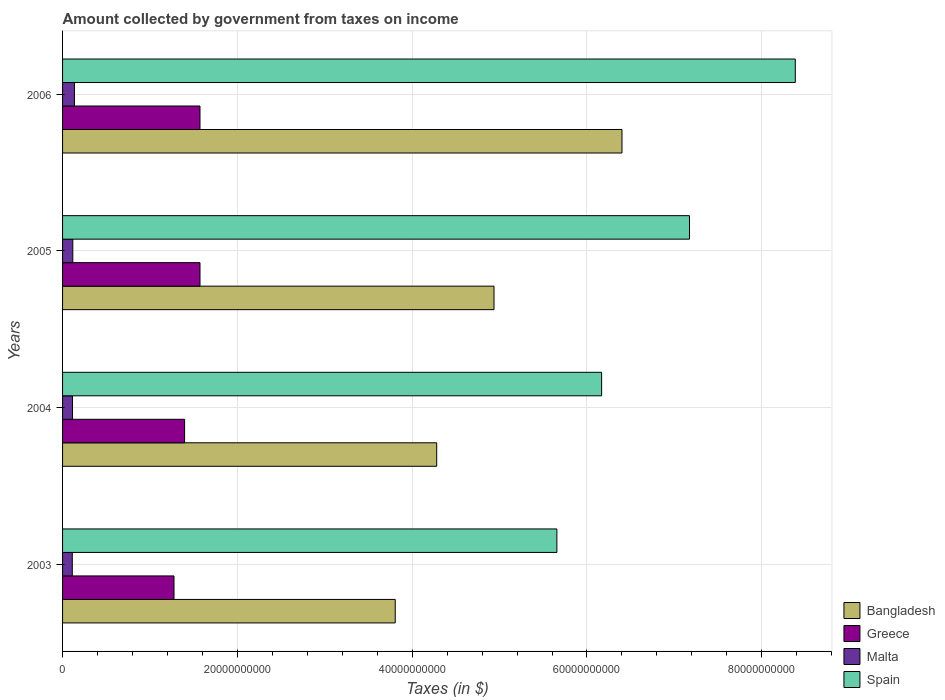How many groups of bars are there?
Ensure brevity in your answer.  4. Are the number of bars per tick equal to the number of legend labels?
Ensure brevity in your answer.  Yes. How many bars are there on the 4th tick from the top?
Provide a short and direct response. 4. How many bars are there on the 1st tick from the bottom?
Offer a terse response. 4. What is the label of the 2nd group of bars from the top?
Provide a short and direct response. 2005. In how many cases, is the number of bars for a given year not equal to the number of legend labels?
Your response must be concise. 0. What is the amount collected by government from taxes on income in Bangladesh in 2003?
Your response must be concise. 3.81e+1. Across all years, what is the maximum amount collected by government from taxes on income in Malta?
Give a very brief answer. 1.36e+09. Across all years, what is the minimum amount collected by government from taxes on income in Spain?
Ensure brevity in your answer.  5.66e+1. What is the total amount collected by government from taxes on income in Spain in the graph?
Keep it short and to the point. 2.74e+11. What is the difference between the amount collected by government from taxes on income in Spain in 2004 and the amount collected by government from taxes on income in Malta in 2006?
Offer a terse response. 6.03e+1. What is the average amount collected by government from taxes on income in Greece per year?
Offer a very short reply. 1.45e+1. In the year 2006, what is the difference between the amount collected by government from taxes on income in Greece and amount collected by government from taxes on income in Spain?
Your response must be concise. -6.81e+1. In how many years, is the amount collected by government from taxes on income in Bangladesh greater than 84000000000 $?
Make the answer very short. 0. What is the ratio of the amount collected by government from taxes on income in Greece in 2003 to that in 2004?
Offer a terse response. 0.91. Is the amount collected by government from taxes on income in Bangladesh in 2004 less than that in 2006?
Offer a very short reply. Yes. Is the difference between the amount collected by government from taxes on income in Greece in 2003 and 2005 greater than the difference between the amount collected by government from taxes on income in Spain in 2003 and 2005?
Your answer should be very brief. Yes. What is the difference between the highest and the second highest amount collected by government from taxes on income in Bangladesh?
Give a very brief answer. 1.46e+1. What is the difference between the highest and the lowest amount collected by government from taxes on income in Spain?
Your response must be concise. 2.73e+1. Is the sum of the amount collected by government from taxes on income in Malta in 2003 and 2004 greater than the maximum amount collected by government from taxes on income in Spain across all years?
Your answer should be very brief. No. Is it the case that in every year, the sum of the amount collected by government from taxes on income in Malta and amount collected by government from taxes on income in Spain is greater than the sum of amount collected by government from taxes on income in Greece and amount collected by government from taxes on income in Bangladesh?
Your answer should be compact. No. What does the 3rd bar from the bottom in 2006 represents?
Provide a short and direct response. Malta. What is the difference between two consecutive major ticks on the X-axis?
Offer a very short reply. 2.00e+1. Does the graph contain grids?
Offer a terse response. Yes. How many legend labels are there?
Provide a short and direct response. 4. What is the title of the graph?
Make the answer very short. Amount collected by government from taxes on income. Does "Sint Maarten (Dutch part)" appear as one of the legend labels in the graph?
Give a very brief answer. No. What is the label or title of the X-axis?
Ensure brevity in your answer.  Taxes (in $). What is the label or title of the Y-axis?
Keep it short and to the point. Years. What is the Taxes (in $) in Bangladesh in 2003?
Offer a very short reply. 3.81e+1. What is the Taxes (in $) in Greece in 2003?
Your response must be concise. 1.28e+1. What is the Taxes (in $) of Malta in 2003?
Offer a very short reply. 1.11e+09. What is the Taxes (in $) in Spain in 2003?
Your response must be concise. 5.66e+1. What is the Taxes (in $) of Bangladesh in 2004?
Give a very brief answer. 4.28e+1. What is the Taxes (in $) in Greece in 2004?
Provide a succinct answer. 1.40e+1. What is the Taxes (in $) in Malta in 2004?
Keep it short and to the point. 1.14e+09. What is the Taxes (in $) in Spain in 2004?
Keep it short and to the point. 6.17e+1. What is the Taxes (in $) of Bangladesh in 2005?
Provide a succinct answer. 4.94e+1. What is the Taxes (in $) of Greece in 2005?
Offer a terse response. 1.57e+1. What is the Taxes (in $) in Malta in 2005?
Give a very brief answer. 1.17e+09. What is the Taxes (in $) of Spain in 2005?
Your answer should be very brief. 7.17e+1. What is the Taxes (in $) in Bangladesh in 2006?
Your response must be concise. 6.40e+1. What is the Taxes (in $) in Greece in 2006?
Your answer should be compact. 1.57e+1. What is the Taxes (in $) in Malta in 2006?
Your response must be concise. 1.36e+09. What is the Taxes (in $) in Spain in 2006?
Provide a succinct answer. 8.38e+1. Across all years, what is the maximum Taxes (in $) of Bangladesh?
Offer a very short reply. 6.40e+1. Across all years, what is the maximum Taxes (in $) in Greece?
Provide a short and direct response. 1.57e+1. Across all years, what is the maximum Taxes (in $) in Malta?
Offer a terse response. 1.36e+09. Across all years, what is the maximum Taxes (in $) in Spain?
Your answer should be very brief. 8.38e+1. Across all years, what is the minimum Taxes (in $) in Bangladesh?
Ensure brevity in your answer.  3.81e+1. Across all years, what is the minimum Taxes (in $) of Greece?
Keep it short and to the point. 1.28e+1. Across all years, what is the minimum Taxes (in $) of Malta?
Provide a succinct answer. 1.11e+09. Across all years, what is the minimum Taxes (in $) in Spain?
Your response must be concise. 5.66e+1. What is the total Taxes (in $) in Bangladesh in the graph?
Give a very brief answer. 1.94e+11. What is the total Taxes (in $) in Greece in the graph?
Offer a very short reply. 5.82e+1. What is the total Taxes (in $) of Malta in the graph?
Provide a short and direct response. 4.78e+09. What is the total Taxes (in $) of Spain in the graph?
Offer a very short reply. 2.74e+11. What is the difference between the Taxes (in $) of Bangladesh in 2003 and that in 2004?
Your answer should be compact. -4.74e+09. What is the difference between the Taxes (in $) in Greece in 2003 and that in 2004?
Keep it short and to the point. -1.21e+09. What is the difference between the Taxes (in $) in Malta in 2003 and that in 2004?
Keep it short and to the point. -2.56e+07. What is the difference between the Taxes (in $) of Spain in 2003 and that in 2004?
Make the answer very short. -5.12e+09. What is the difference between the Taxes (in $) of Bangladesh in 2003 and that in 2005?
Make the answer very short. -1.13e+1. What is the difference between the Taxes (in $) in Greece in 2003 and that in 2005?
Keep it short and to the point. -2.97e+09. What is the difference between the Taxes (in $) of Malta in 2003 and that in 2005?
Your answer should be compact. -5.76e+07. What is the difference between the Taxes (in $) of Spain in 2003 and that in 2005?
Provide a succinct answer. -1.52e+1. What is the difference between the Taxes (in $) in Bangladesh in 2003 and that in 2006?
Keep it short and to the point. -2.59e+1. What is the difference between the Taxes (in $) of Greece in 2003 and that in 2006?
Your response must be concise. -2.97e+09. What is the difference between the Taxes (in $) in Malta in 2003 and that in 2006?
Offer a very short reply. -2.47e+08. What is the difference between the Taxes (in $) of Spain in 2003 and that in 2006?
Make the answer very short. -2.73e+1. What is the difference between the Taxes (in $) of Bangladesh in 2004 and that in 2005?
Provide a succinct answer. -6.56e+09. What is the difference between the Taxes (in $) of Greece in 2004 and that in 2005?
Offer a terse response. -1.76e+09. What is the difference between the Taxes (in $) in Malta in 2004 and that in 2005?
Keep it short and to the point. -3.20e+07. What is the difference between the Taxes (in $) in Spain in 2004 and that in 2005?
Make the answer very short. -1.01e+1. What is the difference between the Taxes (in $) in Bangladesh in 2004 and that in 2006?
Your answer should be compact. -2.12e+1. What is the difference between the Taxes (in $) of Greece in 2004 and that in 2006?
Keep it short and to the point. -1.76e+09. What is the difference between the Taxes (in $) in Malta in 2004 and that in 2006?
Make the answer very short. -2.22e+08. What is the difference between the Taxes (in $) of Spain in 2004 and that in 2006?
Your answer should be very brief. -2.22e+1. What is the difference between the Taxes (in $) of Bangladesh in 2005 and that in 2006?
Provide a succinct answer. -1.46e+1. What is the difference between the Taxes (in $) in Malta in 2005 and that in 2006?
Make the answer very short. -1.90e+08. What is the difference between the Taxes (in $) in Spain in 2005 and that in 2006?
Your response must be concise. -1.21e+1. What is the difference between the Taxes (in $) in Bangladesh in 2003 and the Taxes (in $) in Greece in 2004?
Offer a very short reply. 2.41e+1. What is the difference between the Taxes (in $) of Bangladesh in 2003 and the Taxes (in $) of Malta in 2004?
Your answer should be compact. 3.69e+1. What is the difference between the Taxes (in $) of Bangladesh in 2003 and the Taxes (in $) of Spain in 2004?
Provide a short and direct response. -2.36e+1. What is the difference between the Taxes (in $) in Greece in 2003 and the Taxes (in $) in Malta in 2004?
Give a very brief answer. 1.16e+1. What is the difference between the Taxes (in $) in Greece in 2003 and the Taxes (in $) in Spain in 2004?
Ensure brevity in your answer.  -4.89e+1. What is the difference between the Taxes (in $) in Malta in 2003 and the Taxes (in $) in Spain in 2004?
Ensure brevity in your answer.  -6.06e+1. What is the difference between the Taxes (in $) in Bangladesh in 2003 and the Taxes (in $) in Greece in 2005?
Make the answer very short. 2.23e+1. What is the difference between the Taxes (in $) in Bangladesh in 2003 and the Taxes (in $) in Malta in 2005?
Your answer should be compact. 3.69e+1. What is the difference between the Taxes (in $) in Bangladesh in 2003 and the Taxes (in $) in Spain in 2005?
Give a very brief answer. -3.37e+1. What is the difference between the Taxes (in $) in Greece in 2003 and the Taxes (in $) in Malta in 2005?
Offer a terse response. 1.16e+1. What is the difference between the Taxes (in $) in Greece in 2003 and the Taxes (in $) in Spain in 2005?
Offer a very short reply. -5.90e+1. What is the difference between the Taxes (in $) of Malta in 2003 and the Taxes (in $) of Spain in 2005?
Ensure brevity in your answer.  -7.06e+1. What is the difference between the Taxes (in $) in Bangladesh in 2003 and the Taxes (in $) in Greece in 2006?
Offer a very short reply. 2.23e+1. What is the difference between the Taxes (in $) of Bangladesh in 2003 and the Taxes (in $) of Malta in 2006?
Your response must be concise. 3.67e+1. What is the difference between the Taxes (in $) in Bangladesh in 2003 and the Taxes (in $) in Spain in 2006?
Your response must be concise. -4.58e+1. What is the difference between the Taxes (in $) of Greece in 2003 and the Taxes (in $) of Malta in 2006?
Make the answer very short. 1.14e+1. What is the difference between the Taxes (in $) of Greece in 2003 and the Taxes (in $) of Spain in 2006?
Provide a succinct answer. -7.11e+1. What is the difference between the Taxes (in $) of Malta in 2003 and the Taxes (in $) of Spain in 2006?
Your answer should be very brief. -8.27e+1. What is the difference between the Taxes (in $) in Bangladesh in 2004 and the Taxes (in $) in Greece in 2005?
Your answer should be very brief. 2.71e+1. What is the difference between the Taxes (in $) of Bangladesh in 2004 and the Taxes (in $) of Malta in 2005?
Ensure brevity in your answer.  4.16e+1. What is the difference between the Taxes (in $) in Bangladesh in 2004 and the Taxes (in $) in Spain in 2005?
Offer a terse response. -2.89e+1. What is the difference between the Taxes (in $) in Greece in 2004 and the Taxes (in $) in Malta in 2005?
Keep it short and to the point. 1.28e+1. What is the difference between the Taxes (in $) of Greece in 2004 and the Taxes (in $) of Spain in 2005?
Offer a very short reply. -5.78e+1. What is the difference between the Taxes (in $) of Malta in 2004 and the Taxes (in $) of Spain in 2005?
Your answer should be compact. -7.06e+1. What is the difference between the Taxes (in $) in Bangladesh in 2004 and the Taxes (in $) in Greece in 2006?
Offer a very short reply. 2.71e+1. What is the difference between the Taxes (in $) of Bangladesh in 2004 and the Taxes (in $) of Malta in 2006?
Keep it short and to the point. 4.14e+1. What is the difference between the Taxes (in $) in Bangladesh in 2004 and the Taxes (in $) in Spain in 2006?
Provide a succinct answer. -4.10e+1. What is the difference between the Taxes (in $) of Greece in 2004 and the Taxes (in $) of Malta in 2006?
Give a very brief answer. 1.26e+1. What is the difference between the Taxes (in $) of Greece in 2004 and the Taxes (in $) of Spain in 2006?
Your answer should be compact. -6.99e+1. What is the difference between the Taxes (in $) in Malta in 2004 and the Taxes (in $) in Spain in 2006?
Offer a terse response. -8.27e+1. What is the difference between the Taxes (in $) in Bangladesh in 2005 and the Taxes (in $) in Greece in 2006?
Give a very brief answer. 3.36e+1. What is the difference between the Taxes (in $) of Bangladesh in 2005 and the Taxes (in $) of Malta in 2006?
Keep it short and to the point. 4.80e+1. What is the difference between the Taxes (in $) in Bangladesh in 2005 and the Taxes (in $) in Spain in 2006?
Offer a very short reply. -3.45e+1. What is the difference between the Taxes (in $) of Greece in 2005 and the Taxes (in $) of Malta in 2006?
Provide a succinct answer. 1.44e+1. What is the difference between the Taxes (in $) in Greece in 2005 and the Taxes (in $) in Spain in 2006?
Your answer should be very brief. -6.81e+1. What is the difference between the Taxes (in $) in Malta in 2005 and the Taxes (in $) in Spain in 2006?
Ensure brevity in your answer.  -8.27e+1. What is the average Taxes (in $) in Bangladesh per year?
Your response must be concise. 4.86e+1. What is the average Taxes (in $) in Greece per year?
Your response must be concise. 1.45e+1. What is the average Taxes (in $) of Malta per year?
Offer a very short reply. 1.20e+09. What is the average Taxes (in $) in Spain per year?
Ensure brevity in your answer.  6.85e+1. In the year 2003, what is the difference between the Taxes (in $) of Bangladesh and Taxes (in $) of Greece?
Make the answer very short. 2.53e+1. In the year 2003, what is the difference between the Taxes (in $) of Bangladesh and Taxes (in $) of Malta?
Provide a short and direct response. 3.70e+1. In the year 2003, what is the difference between the Taxes (in $) in Bangladesh and Taxes (in $) in Spain?
Keep it short and to the point. -1.85e+1. In the year 2003, what is the difference between the Taxes (in $) in Greece and Taxes (in $) in Malta?
Keep it short and to the point. 1.16e+1. In the year 2003, what is the difference between the Taxes (in $) in Greece and Taxes (in $) in Spain?
Offer a terse response. -4.38e+1. In the year 2003, what is the difference between the Taxes (in $) of Malta and Taxes (in $) of Spain?
Offer a very short reply. -5.54e+1. In the year 2004, what is the difference between the Taxes (in $) of Bangladesh and Taxes (in $) of Greece?
Provide a short and direct response. 2.88e+1. In the year 2004, what is the difference between the Taxes (in $) in Bangladesh and Taxes (in $) in Malta?
Provide a succinct answer. 4.17e+1. In the year 2004, what is the difference between the Taxes (in $) of Bangladesh and Taxes (in $) of Spain?
Your answer should be very brief. -1.89e+1. In the year 2004, what is the difference between the Taxes (in $) in Greece and Taxes (in $) in Malta?
Ensure brevity in your answer.  1.28e+1. In the year 2004, what is the difference between the Taxes (in $) in Greece and Taxes (in $) in Spain?
Provide a short and direct response. -4.77e+1. In the year 2004, what is the difference between the Taxes (in $) in Malta and Taxes (in $) in Spain?
Ensure brevity in your answer.  -6.05e+1. In the year 2005, what is the difference between the Taxes (in $) of Bangladesh and Taxes (in $) of Greece?
Your answer should be compact. 3.36e+1. In the year 2005, what is the difference between the Taxes (in $) of Bangladesh and Taxes (in $) of Malta?
Ensure brevity in your answer.  4.82e+1. In the year 2005, what is the difference between the Taxes (in $) in Bangladesh and Taxes (in $) in Spain?
Provide a succinct answer. -2.24e+1. In the year 2005, what is the difference between the Taxes (in $) in Greece and Taxes (in $) in Malta?
Provide a short and direct response. 1.46e+1. In the year 2005, what is the difference between the Taxes (in $) of Greece and Taxes (in $) of Spain?
Your response must be concise. -5.60e+1. In the year 2005, what is the difference between the Taxes (in $) in Malta and Taxes (in $) in Spain?
Provide a short and direct response. -7.06e+1. In the year 2006, what is the difference between the Taxes (in $) in Bangladesh and Taxes (in $) in Greece?
Keep it short and to the point. 4.83e+1. In the year 2006, what is the difference between the Taxes (in $) in Bangladesh and Taxes (in $) in Malta?
Give a very brief answer. 6.26e+1. In the year 2006, what is the difference between the Taxes (in $) in Bangladesh and Taxes (in $) in Spain?
Give a very brief answer. -1.98e+1. In the year 2006, what is the difference between the Taxes (in $) in Greece and Taxes (in $) in Malta?
Provide a succinct answer. 1.44e+1. In the year 2006, what is the difference between the Taxes (in $) of Greece and Taxes (in $) of Spain?
Offer a terse response. -6.81e+1. In the year 2006, what is the difference between the Taxes (in $) of Malta and Taxes (in $) of Spain?
Provide a short and direct response. -8.25e+1. What is the ratio of the Taxes (in $) in Bangladesh in 2003 to that in 2004?
Offer a terse response. 0.89. What is the ratio of the Taxes (in $) in Greece in 2003 to that in 2004?
Provide a succinct answer. 0.91. What is the ratio of the Taxes (in $) in Malta in 2003 to that in 2004?
Ensure brevity in your answer.  0.98. What is the ratio of the Taxes (in $) in Spain in 2003 to that in 2004?
Make the answer very short. 0.92. What is the ratio of the Taxes (in $) of Bangladesh in 2003 to that in 2005?
Provide a short and direct response. 0.77. What is the ratio of the Taxes (in $) of Greece in 2003 to that in 2005?
Keep it short and to the point. 0.81. What is the ratio of the Taxes (in $) in Malta in 2003 to that in 2005?
Give a very brief answer. 0.95. What is the ratio of the Taxes (in $) in Spain in 2003 to that in 2005?
Provide a short and direct response. 0.79. What is the ratio of the Taxes (in $) in Bangladesh in 2003 to that in 2006?
Offer a terse response. 0.59. What is the ratio of the Taxes (in $) of Greece in 2003 to that in 2006?
Your response must be concise. 0.81. What is the ratio of the Taxes (in $) in Malta in 2003 to that in 2006?
Your answer should be compact. 0.82. What is the ratio of the Taxes (in $) of Spain in 2003 to that in 2006?
Provide a short and direct response. 0.67. What is the ratio of the Taxes (in $) in Bangladesh in 2004 to that in 2005?
Provide a succinct answer. 0.87. What is the ratio of the Taxes (in $) in Greece in 2004 to that in 2005?
Offer a very short reply. 0.89. What is the ratio of the Taxes (in $) in Malta in 2004 to that in 2005?
Offer a very short reply. 0.97. What is the ratio of the Taxes (in $) in Spain in 2004 to that in 2005?
Ensure brevity in your answer.  0.86. What is the ratio of the Taxes (in $) of Bangladesh in 2004 to that in 2006?
Keep it short and to the point. 0.67. What is the ratio of the Taxes (in $) in Greece in 2004 to that in 2006?
Give a very brief answer. 0.89. What is the ratio of the Taxes (in $) in Malta in 2004 to that in 2006?
Your response must be concise. 0.84. What is the ratio of the Taxes (in $) in Spain in 2004 to that in 2006?
Your answer should be very brief. 0.74. What is the ratio of the Taxes (in $) in Bangladesh in 2005 to that in 2006?
Your response must be concise. 0.77. What is the ratio of the Taxes (in $) of Greece in 2005 to that in 2006?
Provide a succinct answer. 1. What is the ratio of the Taxes (in $) in Malta in 2005 to that in 2006?
Your answer should be compact. 0.86. What is the ratio of the Taxes (in $) in Spain in 2005 to that in 2006?
Ensure brevity in your answer.  0.86. What is the difference between the highest and the second highest Taxes (in $) in Bangladesh?
Your answer should be compact. 1.46e+1. What is the difference between the highest and the second highest Taxes (in $) in Malta?
Offer a very short reply. 1.90e+08. What is the difference between the highest and the second highest Taxes (in $) of Spain?
Your answer should be compact. 1.21e+1. What is the difference between the highest and the lowest Taxes (in $) of Bangladesh?
Make the answer very short. 2.59e+1. What is the difference between the highest and the lowest Taxes (in $) in Greece?
Your answer should be compact. 2.97e+09. What is the difference between the highest and the lowest Taxes (in $) in Malta?
Offer a very short reply. 2.47e+08. What is the difference between the highest and the lowest Taxes (in $) in Spain?
Make the answer very short. 2.73e+1. 